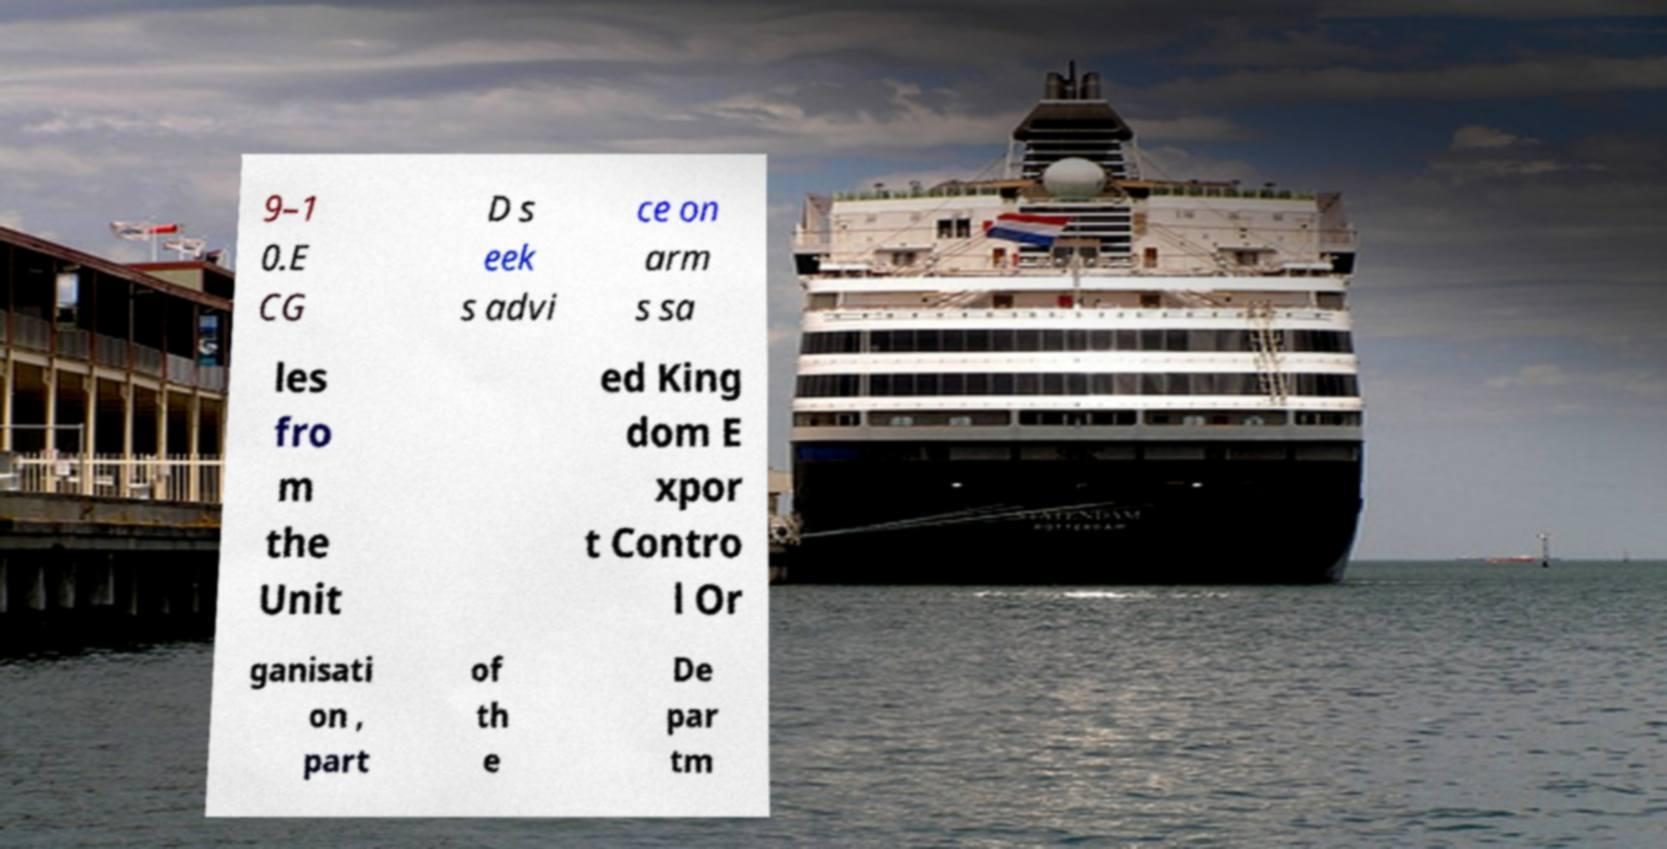Can you accurately transcribe the text from the provided image for me? 9–1 0.E CG D s eek s advi ce on arm s sa les fro m the Unit ed King dom E xpor t Contro l Or ganisati on , part of th e De par tm 